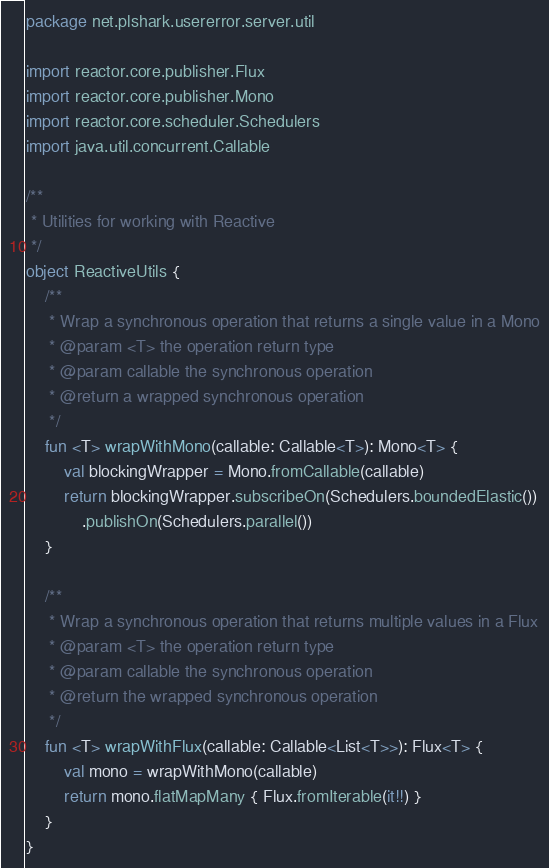<code> <loc_0><loc_0><loc_500><loc_500><_Kotlin_>package net.plshark.usererror.server.util

import reactor.core.publisher.Flux
import reactor.core.publisher.Mono
import reactor.core.scheduler.Schedulers
import java.util.concurrent.Callable

/**
 * Utilities for working with Reactive
 */
object ReactiveUtils {
    /**
     * Wrap a synchronous operation that returns a single value in a Mono
     * @param <T> the operation return type
     * @param callable the synchronous operation
     * @return a wrapped synchronous operation
     */
    fun <T> wrapWithMono(callable: Callable<T>): Mono<T> {
        val blockingWrapper = Mono.fromCallable(callable)
        return blockingWrapper.subscribeOn(Schedulers.boundedElastic())
            .publishOn(Schedulers.parallel())
    }

    /**
     * Wrap a synchronous operation that returns multiple values in a Flux
     * @param <T> the operation return type
     * @param callable the synchronous operation
     * @return the wrapped synchronous operation
     */
    fun <T> wrapWithFlux(callable: Callable<List<T>>): Flux<T> {
        val mono = wrapWithMono(callable)
        return mono.flatMapMany { Flux.fromIterable(it!!) }
    }
}
</code> 